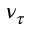Convert formula to latex. <formula><loc_0><loc_0><loc_500><loc_500>\nu _ { \tau }</formula> 